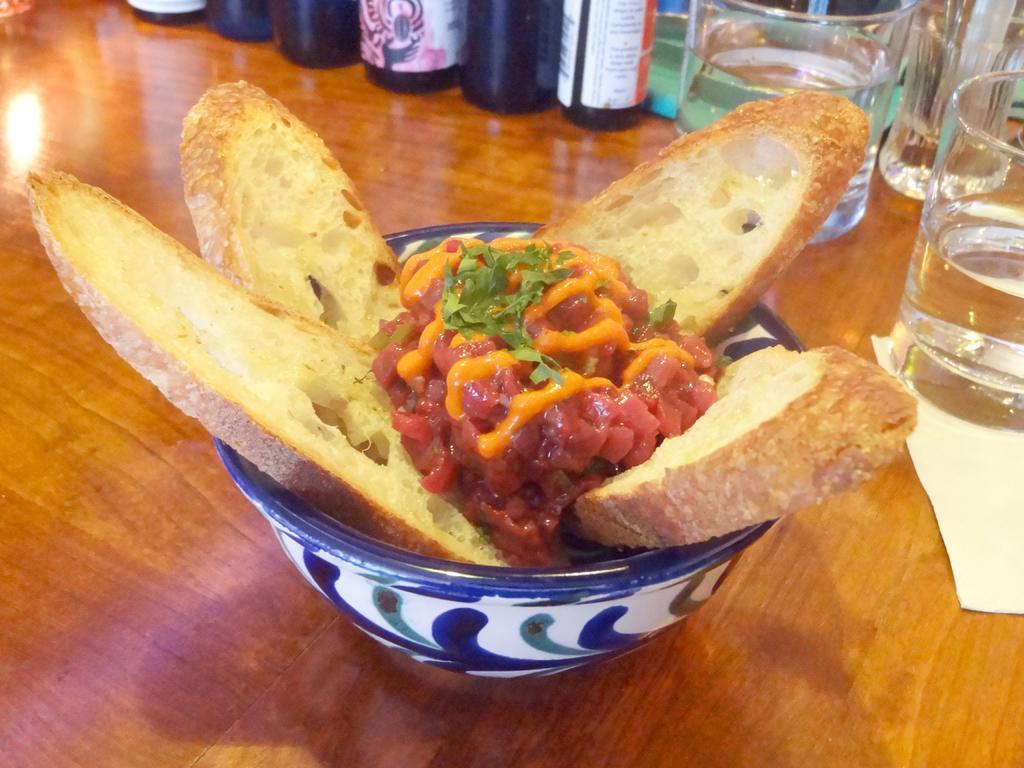How would you summarize this image in a sentence or two? In this image we can see food items in the bowels, there are glasses, bottles, a paper napkin, which are on the wooden surface. 